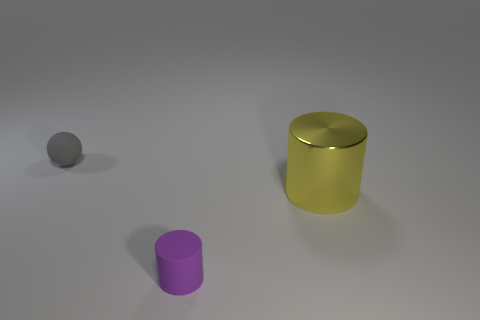Do the yellow metallic thing and the purple thing have the same shape?
Make the answer very short. Yes. What color is the thing that is behind the tiny rubber cylinder and on the left side of the shiny object?
Your response must be concise. Gray. What number of big objects are gray spheres or gray shiny cylinders?
Your response must be concise. 0. Are there any other things that are the same color as the big metal cylinder?
Give a very brief answer. No. The object that is on the left side of the tiny object that is in front of the small thing that is left of the purple cylinder is made of what material?
Give a very brief answer. Rubber. What number of metal objects are either small green objects or large yellow objects?
Provide a short and direct response. 1. How many green things are either large shiny cylinders or small rubber cylinders?
Your answer should be compact. 0. Are the purple object and the tiny sphere made of the same material?
Keep it short and to the point. Yes. Are there an equal number of small gray things in front of the rubber cylinder and large yellow objects behind the yellow cylinder?
Your response must be concise. Yes. There is a small purple thing that is the same shape as the yellow metallic object; what material is it?
Your response must be concise. Rubber. 